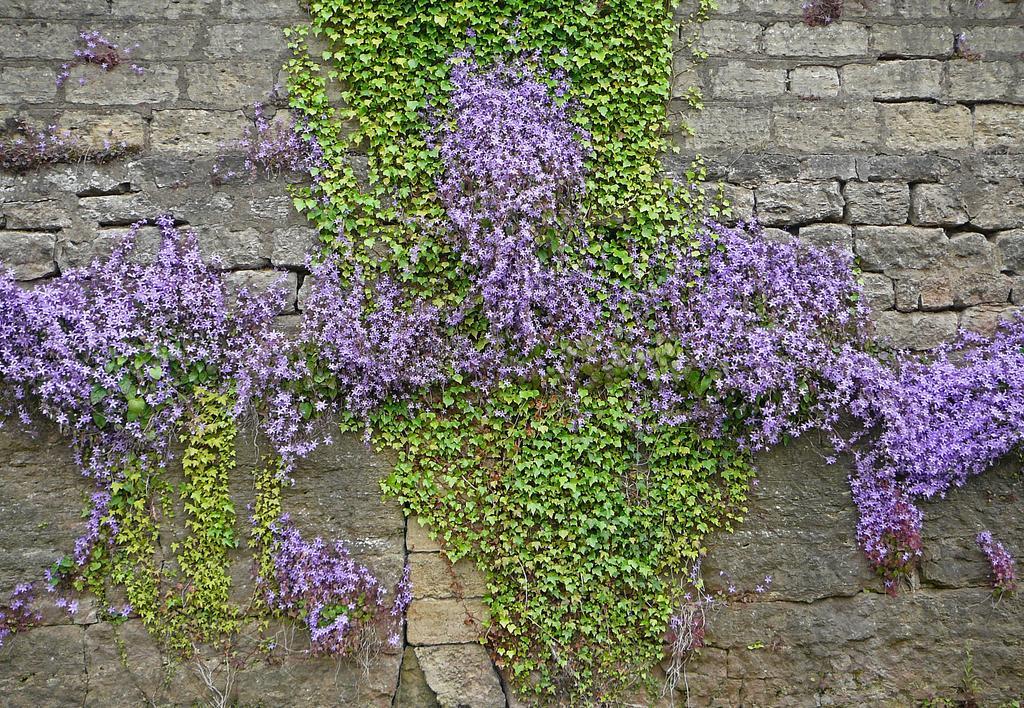Can you describe this image briefly? There are wisteria plants on a stone wall. 